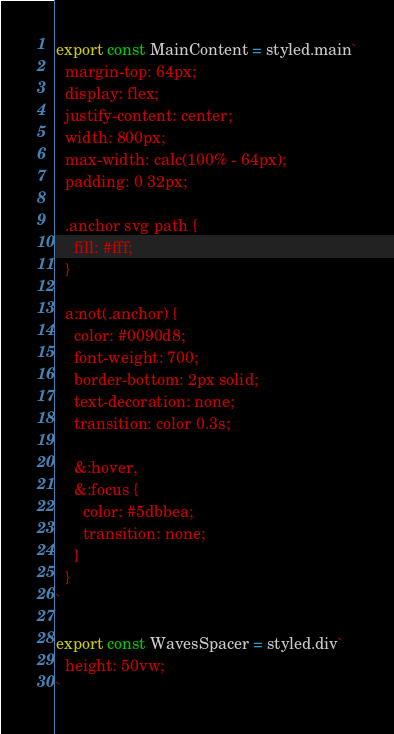Convert code to text. <code><loc_0><loc_0><loc_500><loc_500><_TypeScript_>export const MainContent = styled.main`
  margin-top: 64px;
  display: flex;
  justify-content: center;
  width: 800px;
  max-width: calc(100% - 64px);
  padding: 0 32px;

  .anchor svg path {
    fill: #fff;
  }

  a:not(.anchor) {
    color: #0090d8;
    font-weight: 700;
    border-bottom: 2px solid;
    text-decoration: none;
    transition: color 0.3s;

    &:hover,
    &:focus {
      color: #5dbbea;
      transition: none;
    }
  }
`

export const WavesSpacer = styled.div`
  height: 50vw;
`
</code> 